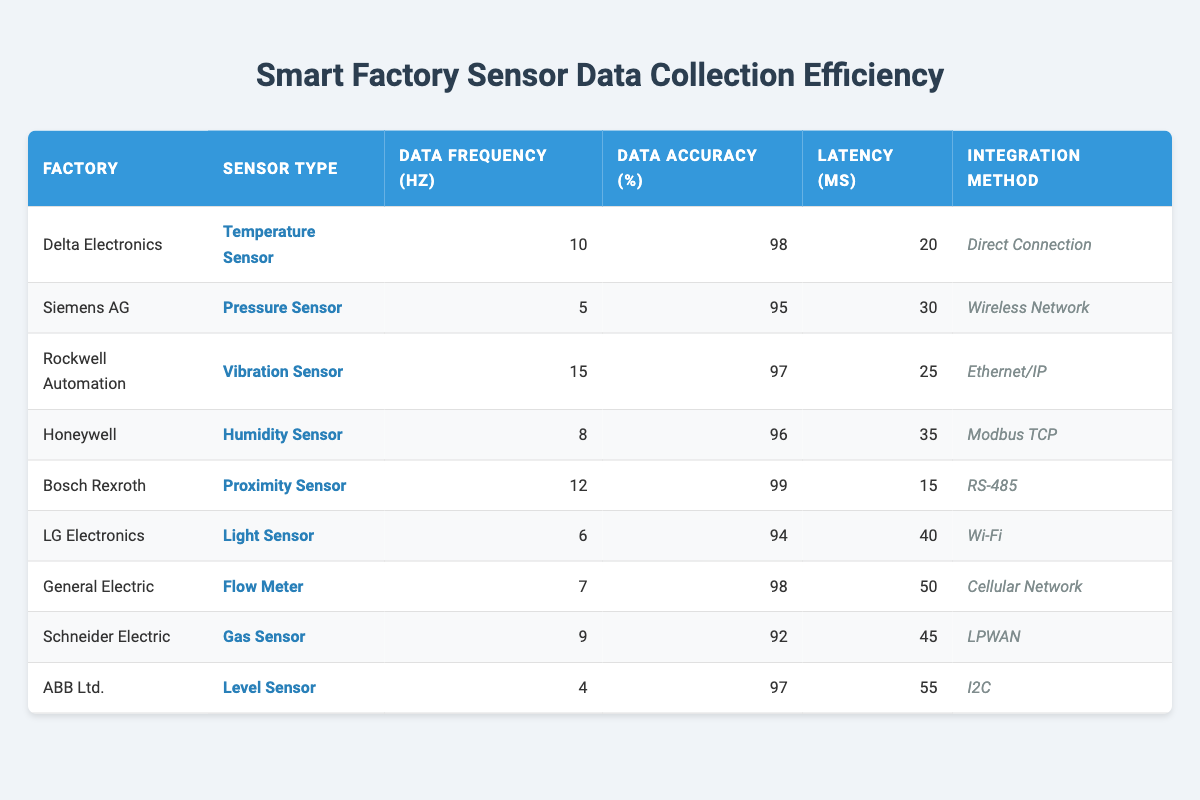What is the data frequency of Bosch Rexroth's Proximity Sensor? The table shows that Bosch Rexroth has a Proximity Sensor with a data frequency of 12 Hz listed under the 'Data Frequency (Hz)' column.
Answer: 12 Hz Which factory has the highest data accuracy percentage? By comparing the 'Data Accuracy (%)' column, Bosch Rexroth has the highest at 99%.
Answer: Bosch Rexroth What is the average latency of all sensors listed in the table? The latencies are 20, 30, 25, 35, 15, 40, 50, 45, and 55 ms. Adding them: (20 + 30 + 25 + 35 + 15 + 40 + 50 + 45 + 55) = 315 ms and dividing by 9 gives an average of 35 ms.
Answer: 35 ms Which sensor type has the lowest data frequency and what is that frequency? The table lists all sensor frequencies. ABB Ltd. has the lowest frequency of 4 Hz in the 'Data Frequency (Hz)' column.
Answer: 4 Hz Is the data accuracy of the Light Sensor from LG Electronics above 90%? The table states that LG Electronics’ Light Sensor has a data accuracy of 94%, which is above 90%.
Answer: Yes What are the integration methods for sensors collected by Schneider Electric and General Electric? Schneider Electric uses LPWAN while General Electric uses Cellular Network, as indicated in their respective rows under the 'Integration Method' column.
Answer: LPWAN and Cellular Network How does the data frequency of the Temperature Sensor at Delta Electronics compare to the Pressure Sensor at Siemens AG? Delta Electronics has a Temperature Sensor with a data frequency of 10 Hz, and Siemens AG has a Pressure Sensor with 5 Hz, meaning Delta's is higher by 5 Hz.
Answer: 10 Hz vs 5 Hz Which factory's sensors have the least latency and what is that latency? The factory with the least latency is Bosch Rexroth, which has a latency of 15 ms listed under the 'Latency (ms)' column.
Answer: 15 ms What is the difference in data accuracy between the humidity sensor and the flow meter? The humidity sensor by Honeywell has 96% accuracy and the flow meter by General Electric has 98%. The difference is 98% - 96% = 2%.
Answer: 2% If you rank the factories by data frequency, which factory appears in third place? The sorted frequencies are 15 Hz (Rockwell Automation), 12 Hz (Bosch Rexroth), and then 10 Hz (Delta Electronics). So Delta Electronics is ranked third.
Answer: Delta Electronics 